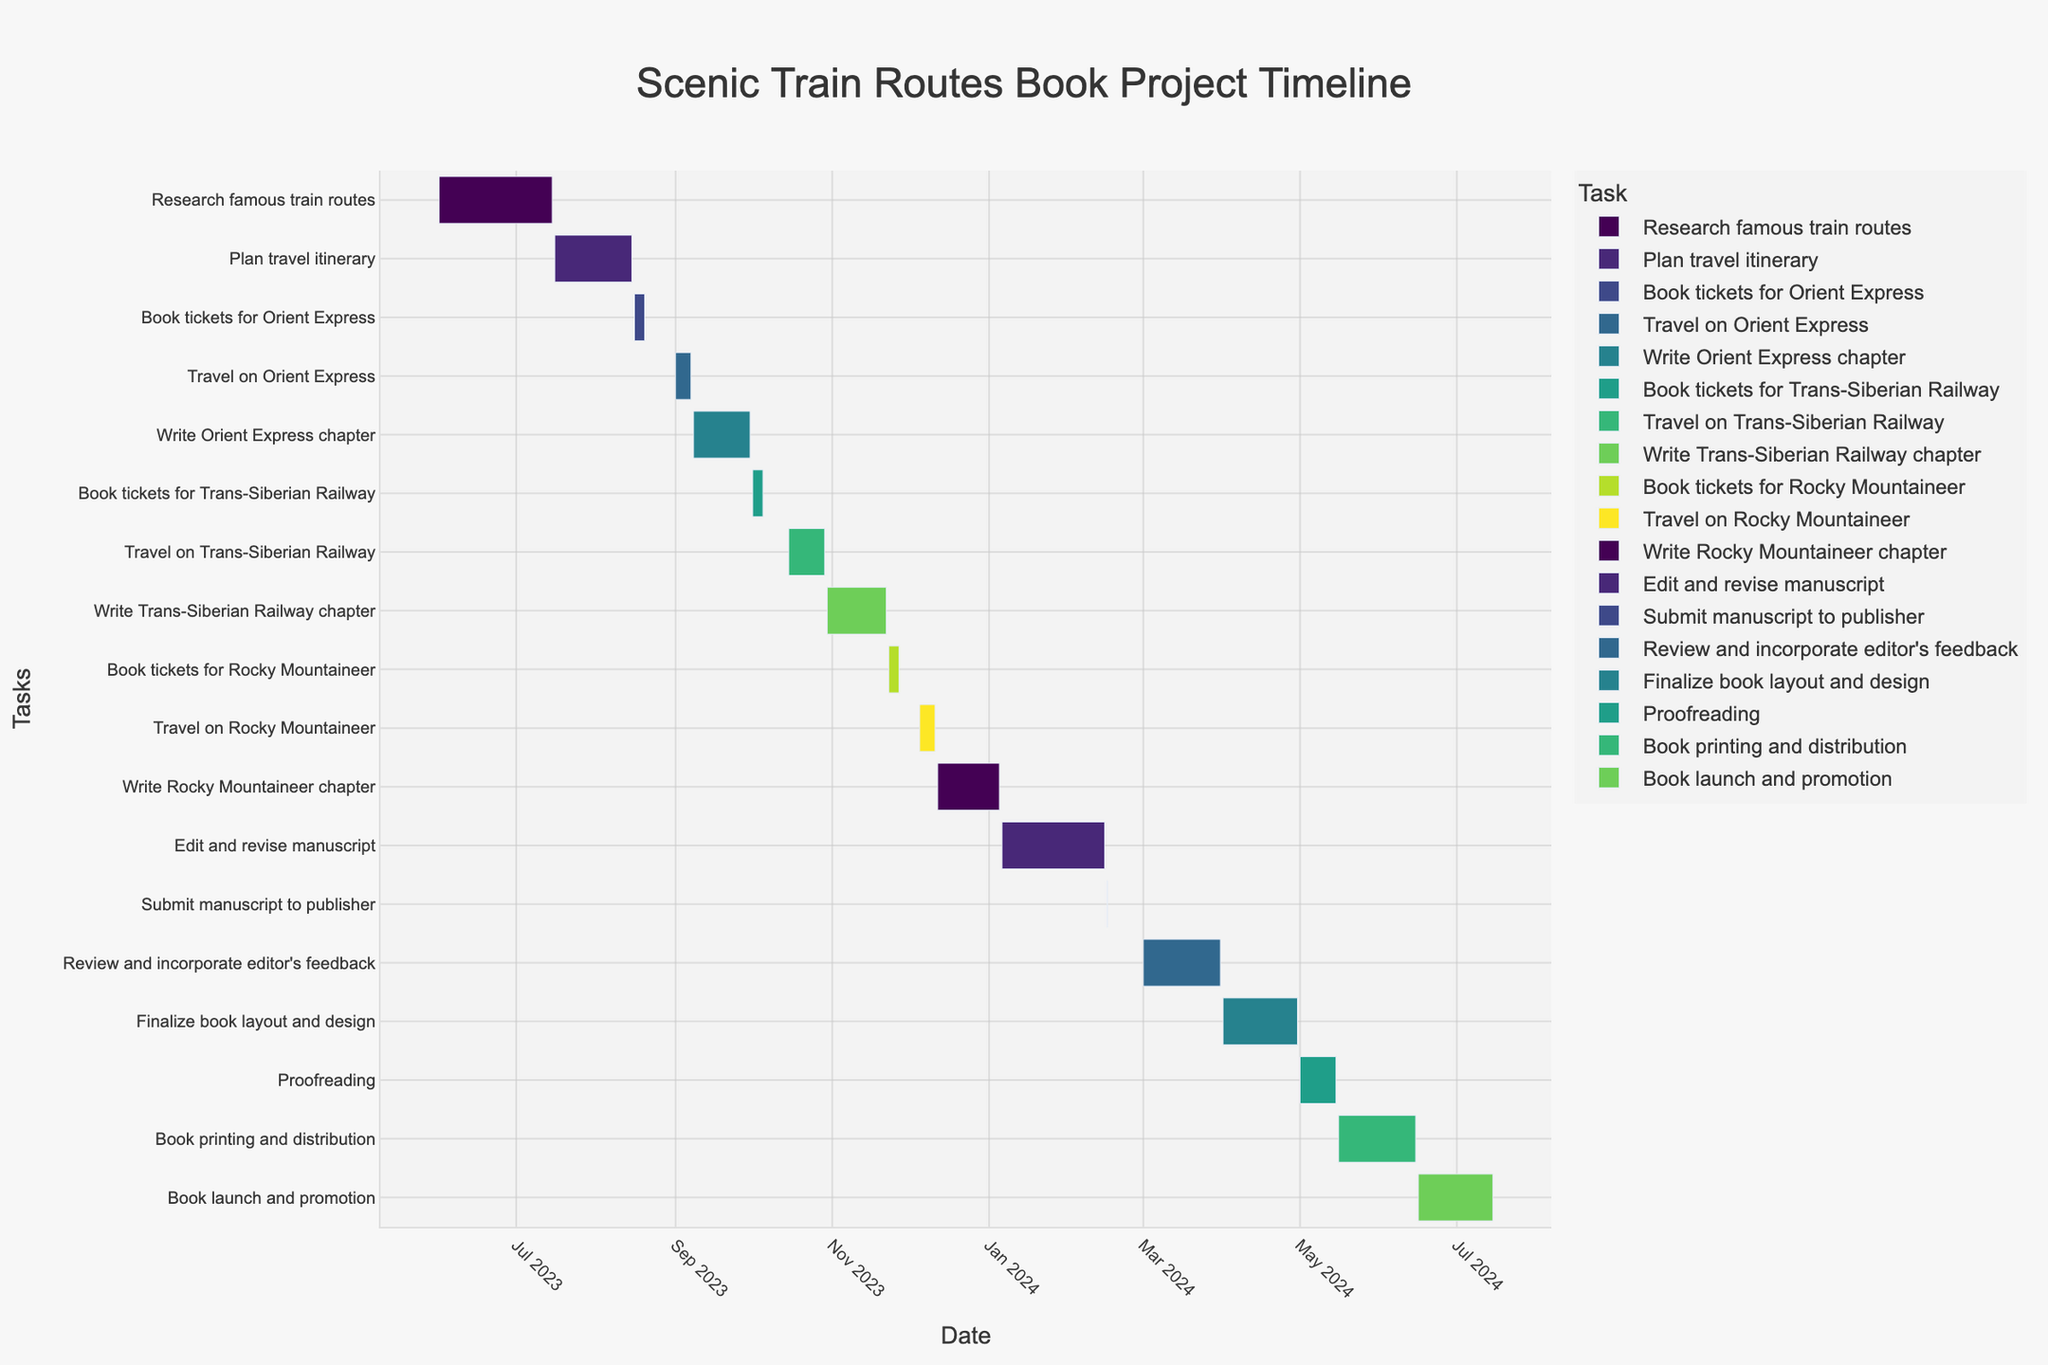How long is the task 'Book tickets for Orient Express'? Locate the task 'Book tickets for Orient Express' on the timeline, note the start and end dates, then calculate the duration as End Date - Start Date (2023-08-20 - 2023-08-16 = 4 days)
Answer: 4 days Which task has the longest duration? Compare the durations of all tasks and find the one with the greatest number of days. The task with the longest duration is 'Book printing and distribution' with a duration spanning from 2024-05-16 to 2024-06-15, totaling to 31 days
Answer: Book printing and distribution How many tasks are planned to be completed in 2024? Count all the tasks with both start and end dates in the year 2024 by inspecting the timeline visually. The tasks are 'Write Rocky Mountaineer chapter,' 'Edit and revise manuscript,' 'Submit manuscript to publisher,' 'Review and incorporate editor's feedback,' 'Finalize book layout and design,' 'Proofreading,' 'Book printing and distribution,' and 'Book launch and promotion'
Answer: 8 tasks When does the task 'Travel on Trans-Siberian Railway' start? Find 'Travel on Trans-Siberian Railway' on the timeline; the start date is shown as 2023-10-15
Answer: 2023-10-15 What is the total duration of all writing-related tasks combined? Identify the tasks related to writing ('Write Orient Express chapter,' 'Write Trans-Siberian Railway chapter,' 'Write Rocky Mountaineer chapter'). Calculate each task's duration and sum them up: 'Write Orient Express chapter' (23 days), 'Write Trans-Siberian Railway chapter' (24 days), 'Write Rocky Mountaineer chapter' (25 days). Summing these gives us (23 + 24 + 25) days
Answer: 72 days Which task has a shorter duration: 'Proofreading' or 'Finalize book layout and design'? Compare the durations of 'Proofreading' (2024-05-01 to 2024-05-15) and 'Finalize book layout and design' (2024-04-01 to 2024-04-30). The durations are 15 days and 30 days respectively
Answer: Proofreading What is the gap between 'Submit manuscript to publisher' and 'Review and incorporate editor's feedback'? Determine the end date of 'Submit manuscript to publisher' (2024-02-16) and start date of 'Review and incorporate editor's feedback' (2024-03-01). Calculate the gap as Start Date - End Date (2024-03-01 - 2024-02-16 = 13 days)
Answer: 13 days How many tasks are there in the final publication stage which includes editing, feedback review, design, proofreading, printing, and launch? Identify the tasks related to publication (beyond writing): 'Edit and revise manuscript,' 'Submit manuscript to publisher,' 'Review and incorporate editor's feedback,' 'Finalize book layout and design,' 'Proofreading,' 'Book printing and distribution,' and 'Book launch and promotion.' Count them
Answer: 7 tasks During which month does the task 'Finalize book layout and design' end? Locate 'Finalize book layout and design' on the timeline and find the end date. It ends on 2024-04-30
Answer: April 